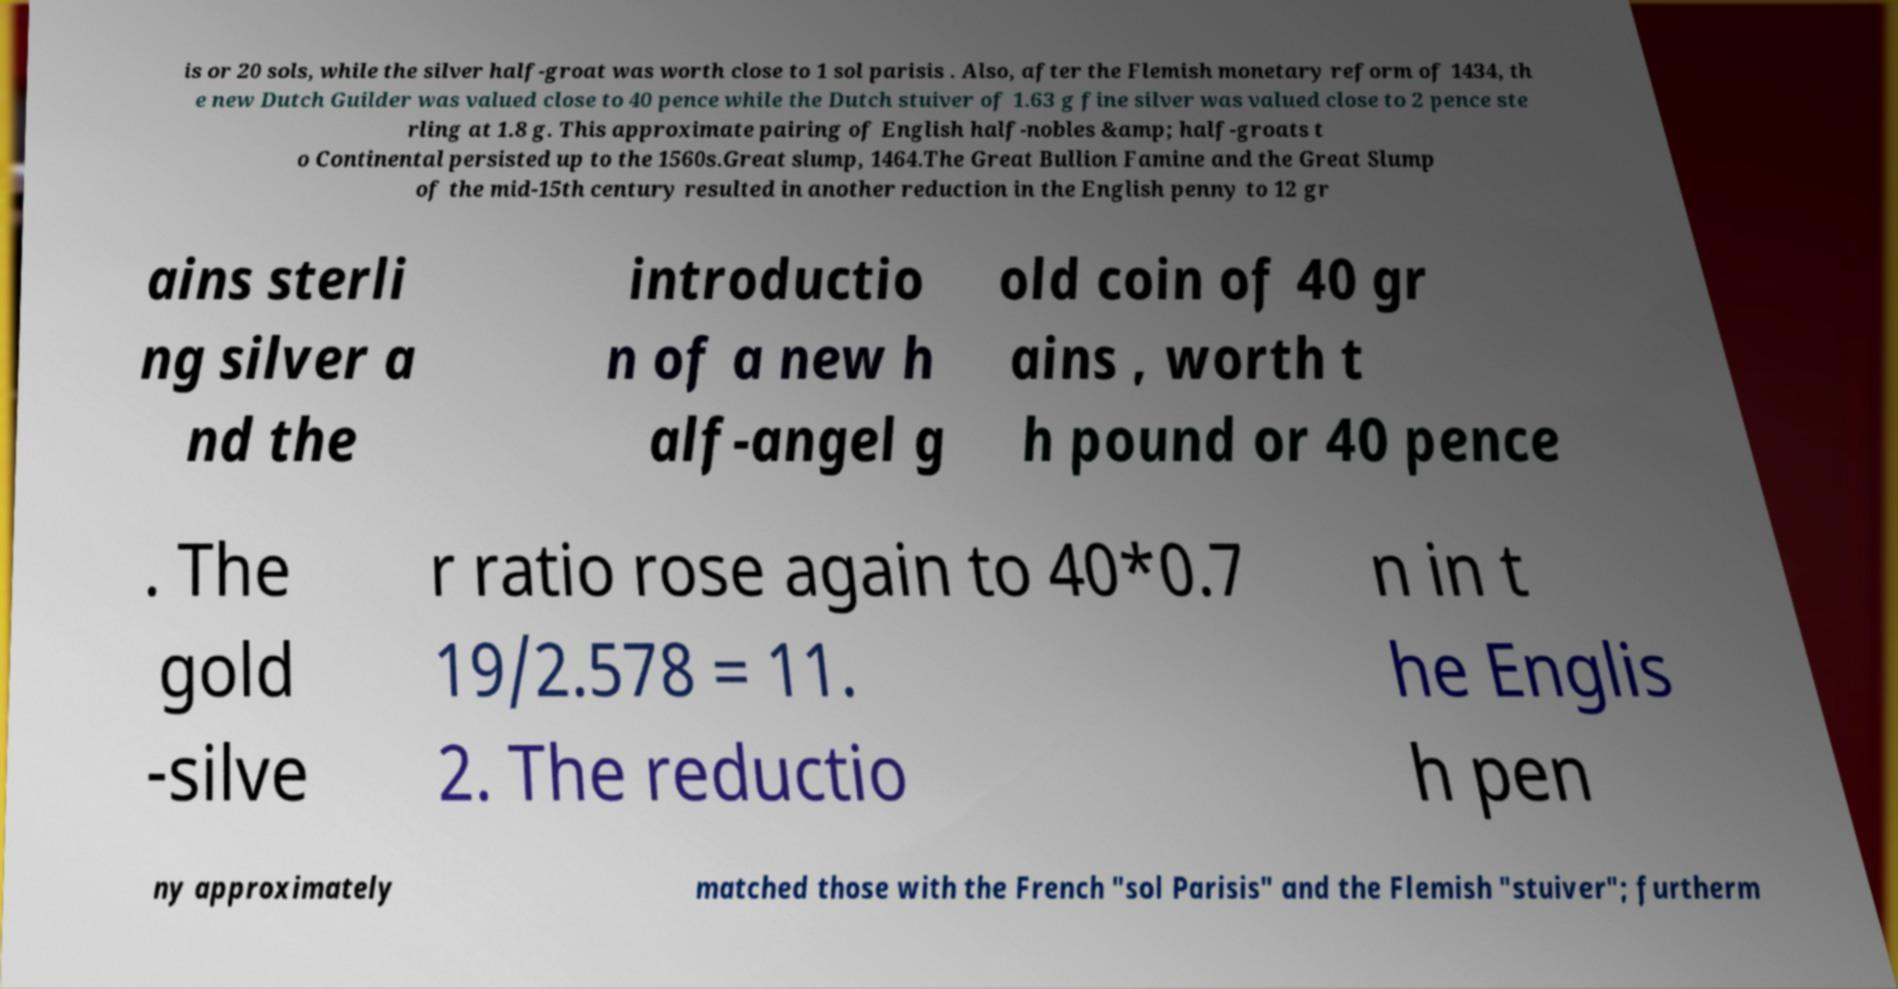Could you assist in decoding the text presented in this image and type it out clearly? is or 20 sols, while the silver half-groat was worth close to 1 sol parisis . Also, after the Flemish monetary reform of 1434, th e new Dutch Guilder was valued close to 40 pence while the Dutch stuiver of 1.63 g fine silver was valued close to 2 pence ste rling at 1.8 g. This approximate pairing of English half-nobles &amp; half-groats t o Continental persisted up to the 1560s.Great slump, 1464.The Great Bullion Famine and the Great Slump of the mid-15th century resulted in another reduction in the English penny to 12 gr ains sterli ng silver a nd the introductio n of a new h alf-angel g old coin of 40 gr ains , worth t h pound or 40 pence . The gold -silve r ratio rose again to 40*0.7 19/2.578 = 11. 2. The reductio n in t he Englis h pen ny approximately matched those with the French "sol Parisis" and the Flemish "stuiver"; furtherm 